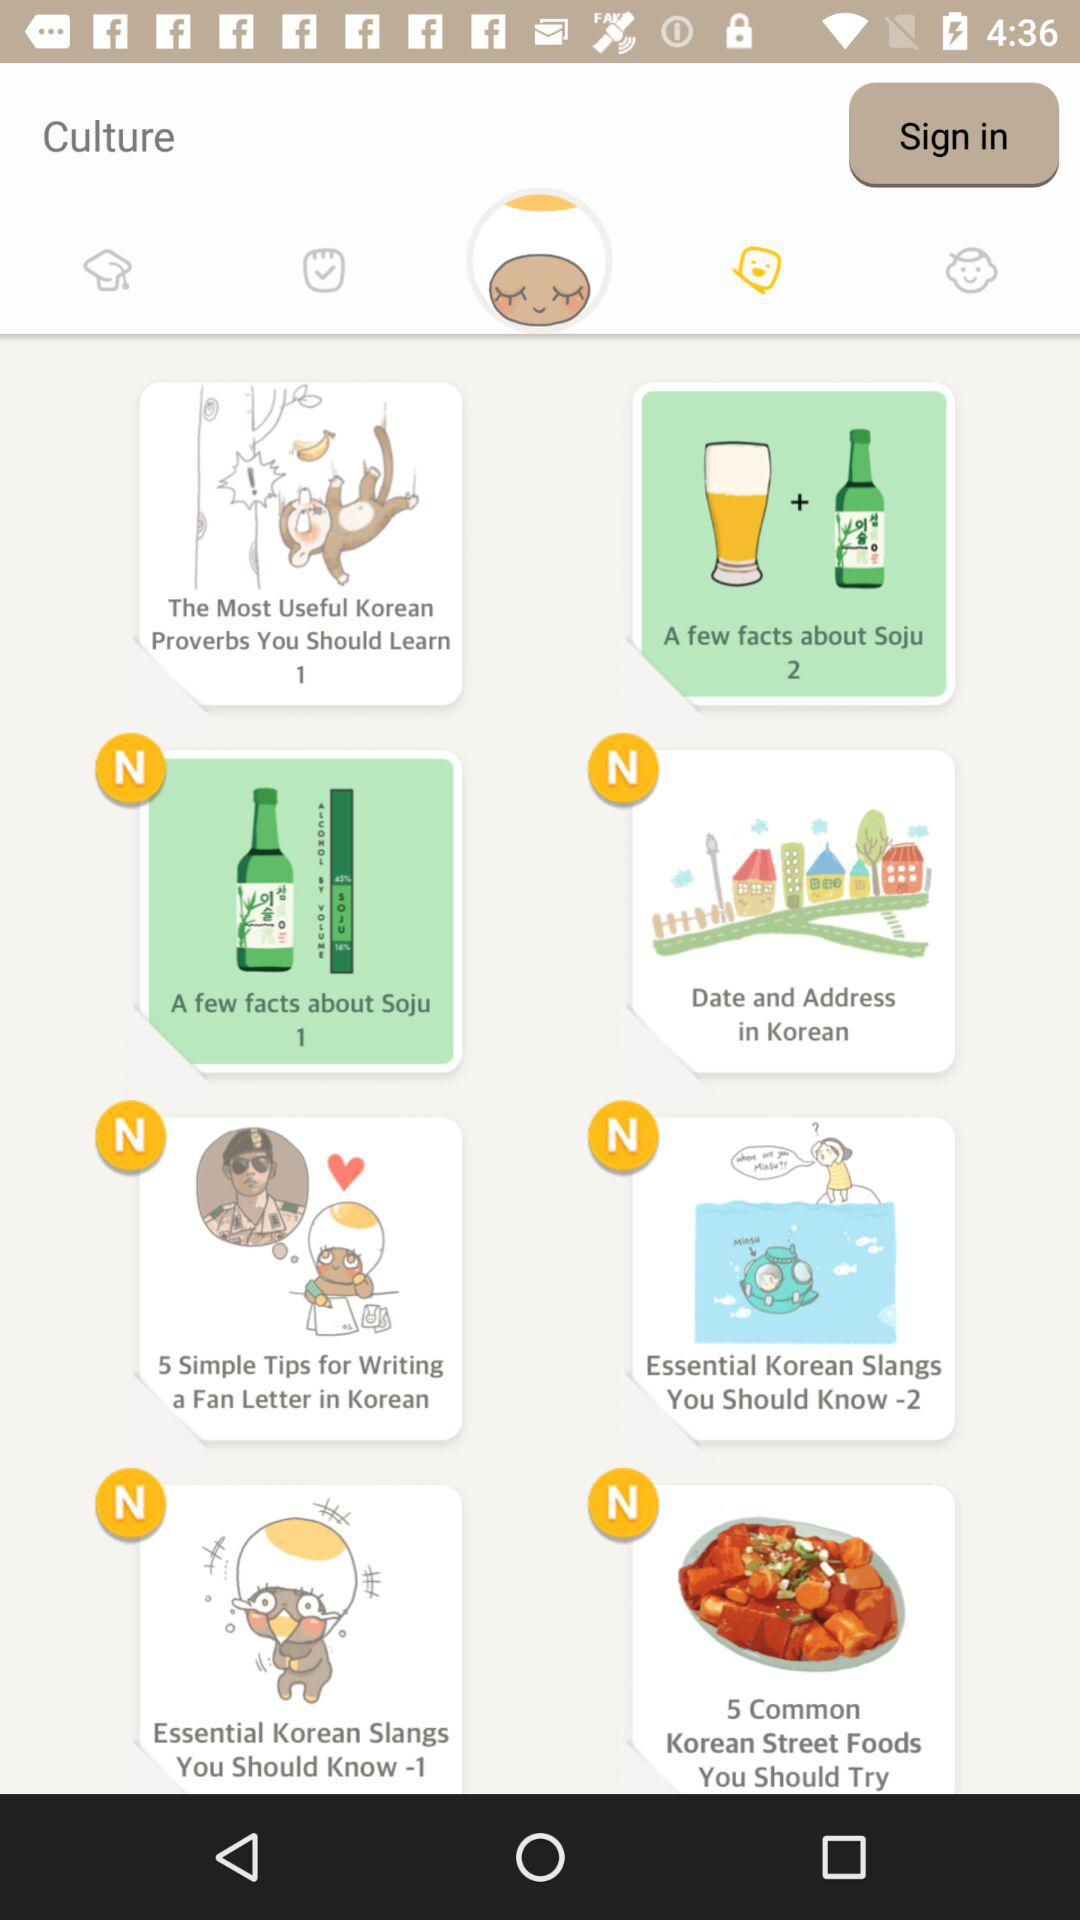What is the application name? The application name is "Culture". 